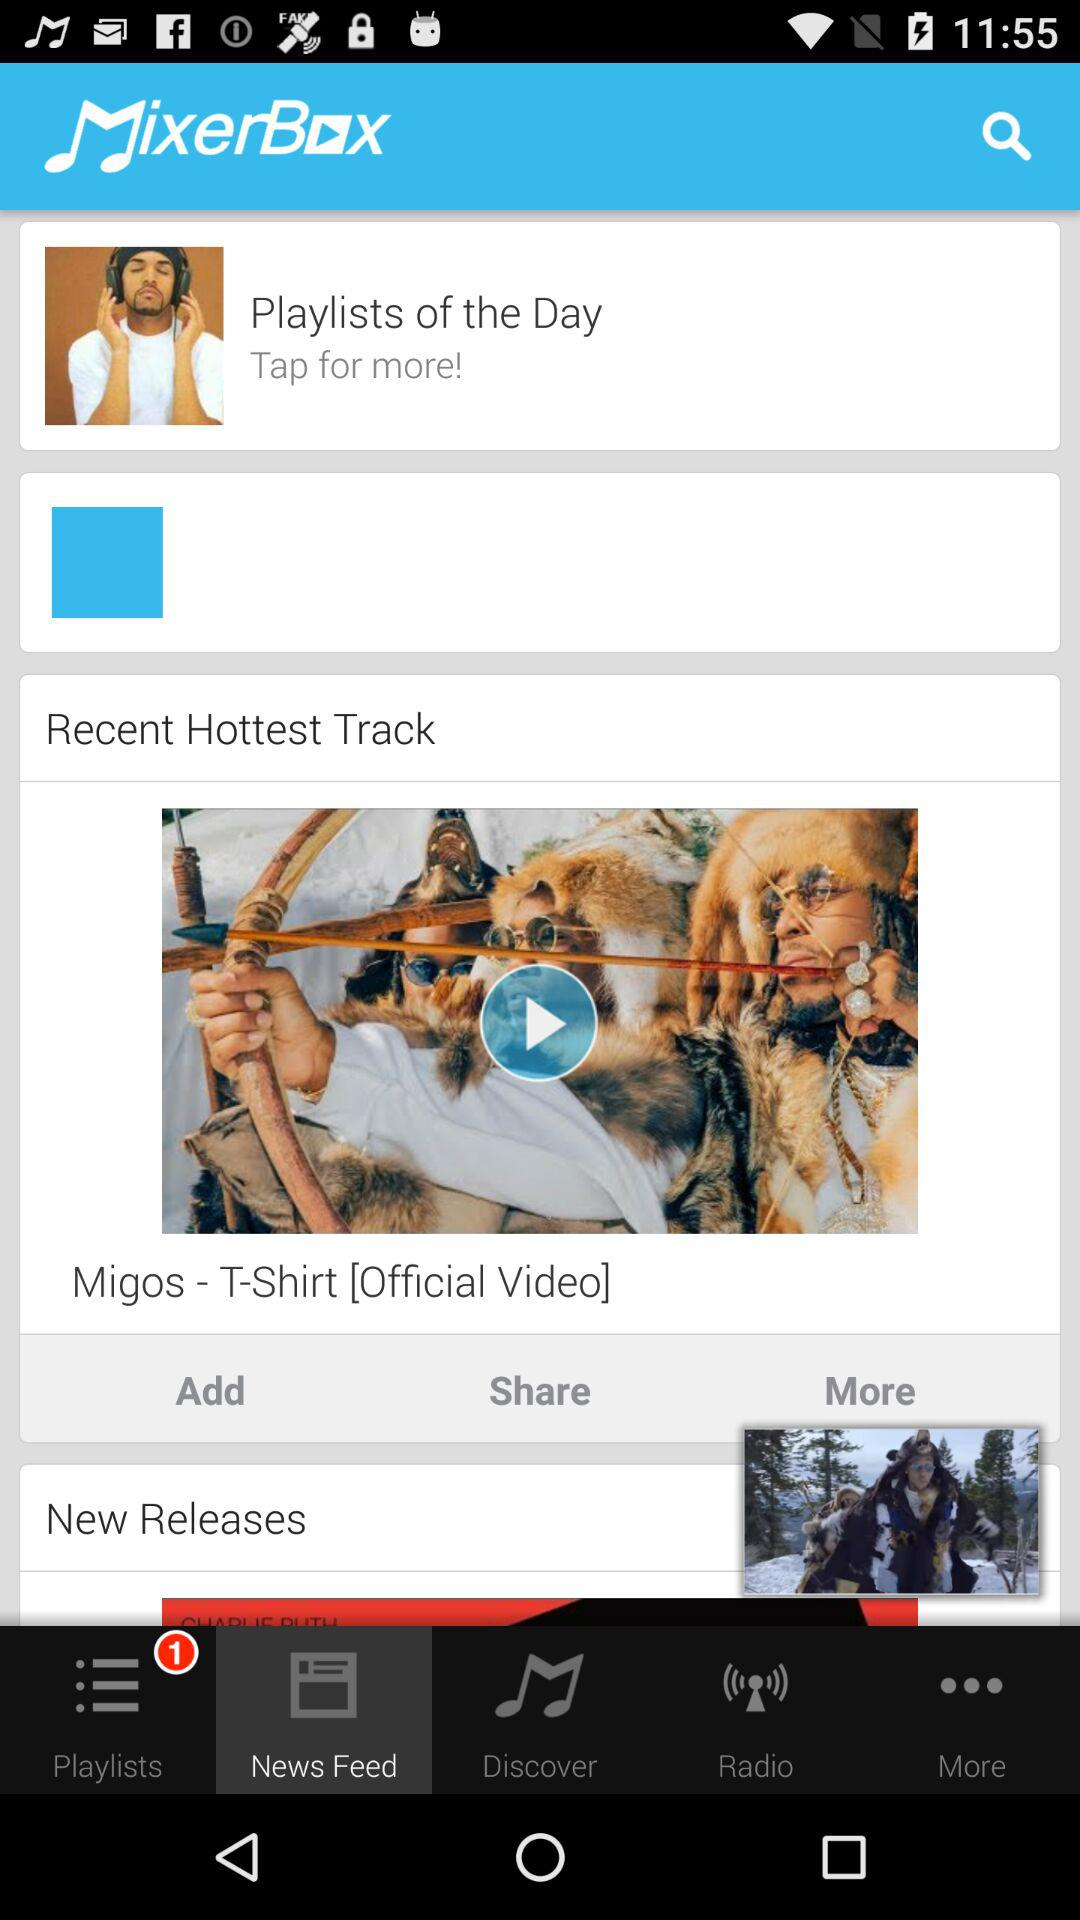What is the app name? The app name is "MixerBox". 